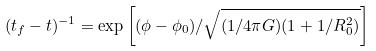<formula> <loc_0><loc_0><loc_500><loc_500>( t _ { f } - t ) ^ { - 1 } = \exp \left [ ( \phi - \phi _ { 0 } ) / \sqrt { ( 1 / 4 \pi G ) ( 1 + 1 / R _ { 0 } ^ { 2 } ) } \right ]</formula> 